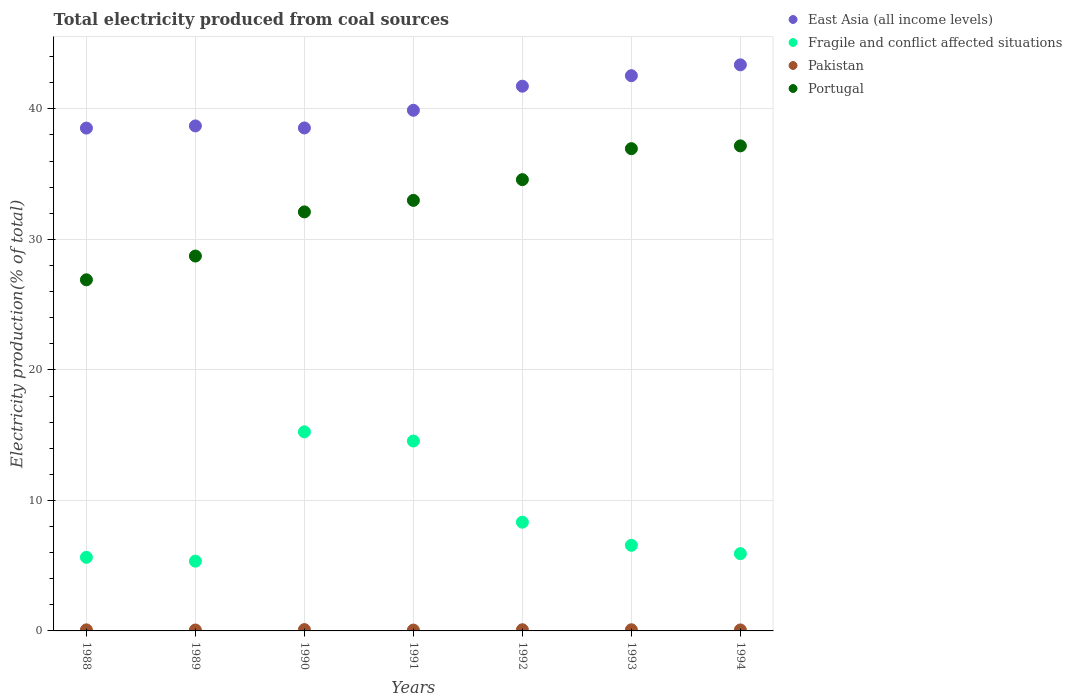How many different coloured dotlines are there?
Your answer should be compact. 4. What is the total electricity produced in Pakistan in 1988?
Offer a very short reply. 0.08. Across all years, what is the maximum total electricity produced in Pakistan?
Keep it short and to the point. 0.1. Across all years, what is the minimum total electricity produced in Portugal?
Make the answer very short. 26.9. In which year was the total electricity produced in Portugal minimum?
Provide a succinct answer. 1988. What is the total total electricity produced in Portugal in the graph?
Give a very brief answer. 229.42. What is the difference between the total electricity produced in Fragile and conflict affected situations in 1990 and that in 1992?
Ensure brevity in your answer.  6.92. What is the difference between the total electricity produced in Portugal in 1992 and the total electricity produced in Pakistan in 1989?
Your answer should be very brief. 34.51. What is the average total electricity produced in East Asia (all income levels) per year?
Your answer should be compact. 40.47. In the year 1990, what is the difference between the total electricity produced in East Asia (all income levels) and total electricity produced in Portugal?
Offer a very short reply. 6.43. What is the ratio of the total electricity produced in Portugal in 1988 to that in 1994?
Your response must be concise. 0.72. Is the difference between the total electricity produced in East Asia (all income levels) in 1993 and 1994 greater than the difference between the total electricity produced in Portugal in 1993 and 1994?
Provide a short and direct response. No. What is the difference between the highest and the second highest total electricity produced in East Asia (all income levels)?
Offer a terse response. 0.83. What is the difference between the highest and the lowest total electricity produced in Fragile and conflict affected situations?
Give a very brief answer. 9.91. In how many years, is the total electricity produced in Fragile and conflict affected situations greater than the average total electricity produced in Fragile and conflict affected situations taken over all years?
Make the answer very short. 2. Is the sum of the total electricity produced in Portugal in 1992 and 1993 greater than the maximum total electricity produced in Pakistan across all years?
Make the answer very short. Yes. Is it the case that in every year, the sum of the total electricity produced in Pakistan and total electricity produced in Portugal  is greater than the sum of total electricity produced in East Asia (all income levels) and total electricity produced in Fragile and conflict affected situations?
Provide a short and direct response. No. Is it the case that in every year, the sum of the total electricity produced in Fragile and conflict affected situations and total electricity produced in Portugal  is greater than the total electricity produced in East Asia (all income levels)?
Offer a very short reply. No. Does the total electricity produced in Portugal monotonically increase over the years?
Your response must be concise. Yes. Is the total electricity produced in East Asia (all income levels) strictly greater than the total electricity produced in Pakistan over the years?
Make the answer very short. Yes. Is the total electricity produced in Portugal strictly less than the total electricity produced in Fragile and conflict affected situations over the years?
Offer a terse response. No. How many years are there in the graph?
Provide a short and direct response. 7. Does the graph contain grids?
Provide a short and direct response. Yes. How many legend labels are there?
Offer a very short reply. 4. What is the title of the graph?
Give a very brief answer. Total electricity produced from coal sources. What is the label or title of the X-axis?
Keep it short and to the point. Years. What is the label or title of the Y-axis?
Your response must be concise. Electricity production(% of total). What is the Electricity production(% of total) in East Asia (all income levels) in 1988?
Your response must be concise. 38.53. What is the Electricity production(% of total) in Fragile and conflict affected situations in 1988?
Give a very brief answer. 5.64. What is the Electricity production(% of total) in Pakistan in 1988?
Keep it short and to the point. 0.08. What is the Electricity production(% of total) of Portugal in 1988?
Offer a very short reply. 26.9. What is the Electricity production(% of total) in East Asia (all income levels) in 1989?
Give a very brief answer. 38.7. What is the Electricity production(% of total) in Fragile and conflict affected situations in 1989?
Ensure brevity in your answer.  5.35. What is the Electricity production(% of total) in Pakistan in 1989?
Make the answer very short. 0.07. What is the Electricity production(% of total) in Portugal in 1989?
Ensure brevity in your answer.  28.73. What is the Electricity production(% of total) of East Asia (all income levels) in 1990?
Your response must be concise. 38.54. What is the Electricity production(% of total) in Fragile and conflict affected situations in 1990?
Your response must be concise. 15.25. What is the Electricity production(% of total) of Pakistan in 1990?
Give a very brief answer. 0.1. What is the Electricity production(% of total) of Portugal in 1990?
Your response must be concise. 32.11. What is the Electricity production(% of total) in East Asia (all income levels) in 1991?
Your response must be concise. 39.89. What is the Electricity production(% of total) in Fragile and conflict affected situations in 1991?
Provide a succinct answer. 14.55. What is the Electricity production(% of total) in Pakistan in 1991?
Provide a short and direct response. 0.07. What is the Electricity production(% of total) of Portugal in 1991?
Provide a short and direct response. 32.99. What is the Electricity production(% of total) in East Asia (all income levels) in 1992?
Ensure brevity in your answer.  41.74. What is the Electricity production(% of total) of Fragile and conflict affected situations in 1992?
Make the answer very short. 8.33. What is the Electricity production(% of total) in Pakistan in 1992?
Offer a very short reply. 0.09. What is the Electricity production(% of total) in Portugal in 1992?
Provide a short and direct response. 34.58. What is the Electricity production(% of total) in East Asia (all income levels) in 1993?
Offer a very short reply. 42.55. What is the Electricity production(% of total) in Fragile and conflict affected situations in 1993?
Offer a terse response. 6.56. What is the Electricity production(% of total) in Pakistan in 1993?
Keep it short and to the point. 0.09. What is the Electricity production(% of total) in Portugal in 1993?
Your response must be concise. 36.95. What is the Electricity production(% of total) of East Asia (all income levels) in 1994?
Your answer should be very brief. 43.38. What is the Electricity production(% of total) in Fragile and conflict affected situations in 1994?
Give a very brief answer. 5.92. What is the Electricity production(% of total) in Pakistan in 1994?
Give a very brief answer. 0.07. What is the Electricity production(% of total) of Portugal in 1994?
Give a very brief answer. 37.17. Across all years, what is the maximum Electricity production(% of total) in East Asia (all income levels)?
Your answer should be compact. 43.38. Across all years, what is the maximum Electricity production(% of total) in Fragile and conflict affected situations?
Your answer should be very brief. 15.25. Across all years, what is the maximum Electricity production(% of total) in Pakistan?
Give a very brief answer. 0.1. Across all years, what is the maximum Electricity production(% of total) in Portugal?
Your response must be concise. 37.17. Across all years, what is the minimum Electricity production(% of total) in East Asia (all income levels)?
Your answer should be compact. 38.53. Across all years, what is the minimum Electricity production(% of total) in Fragile and conflict affected situations?
Ensure brevity in your answer.  5.35. Across all years, what is the minimum Electricity production(% of total) in Pakistan?
Offer a very short reply. 0.07. Across all years, what is the minimum Electricity production(% of total) in Portugal?
Offer a terse response. 26.9. What is the total Electricity production(% of total) in East Asia (all income levels) in the graph?
Your response must be concise. 283.32. What is the total Electricity production(% of total) in Fragile and conflict affected situations in the graph?
Your response must be concise. 61.6. What is the total Electricity production(% of total) in Pakistan in the graph?
Your answer should be very brief. 0.57. What is the total Electricity production(% of total) of Portugal in the graph?
Your answer should be very brief. 229.42. What is the difference between the Electricity production(% of total) of East Asia (all income levels) in 1988 and that in 1989?
Offer a terse response. -0.17. What is the difference between the Electricity production(% of total) in Fragile and conflict affected situations in 1988 and that in 1989?
Provide a succinct answer. 0.29. What is the difference between the Electricity production(% of total) of Pakistan in 1988 and that in 1989?
Offer a terse response. 0.01. What is the difference between the Electricity production(% of total) of Portugal in 1988 and that in 1989?
Make the answer very short. -1.82. What is the difference between the Electricity production(% of total) of East Asia (all income levels) in 1988 and that in 1990?
Your response must be concise. -0.01. What is the difference between the Electricity production(% of total) of Fragile and conflict affected situations in 1988 and that in 1990?
Provide a succinct answer. -9.62. What is the difference between the Electricity production(% of total) in Pakistan in 1988 and that in 1990?
Give a very brief answer. -0.02. What is the difference between the Electricity production(% of total) in Portugal in 1988 and that in 1990?
Ensure brevity in your answer.  -5.2. What is the difference between the Electricity production(% of total) in East Asia (all income levels) in 1988 and that in 1991?
Make the answer very short. -1.36. What is the difference between the Electricity production(% of total) of Fragile and conflict affected situations in 1988 and that in 1991?
Keep it short and to the point. -8.91. What is the difference between the Electricity production(% of total) in Pakistan in 1988 and that in 1991?
Ensure brevity in your answer.  0.02. What is the difference between the Electricity production(% of total) of Portugal in 1988 and that in 1991?
Offer a very short reply. -6.09. What is the difference between the Electricity production(% of total) of East Asia (all income levels) in 1988 and that in 1992?
Offer a terse response. -3.21. What is the difference between the Electricity production(% of total) in Fragile and conflict affected situations in 1988 and that in 1992?
Offer a terse response. -2.69. What is the difference between the Electricity production(% of total) of Pakistan in 1988 and that in 1992?
Keep it short and to the point. -0.01. What is the difference between the Electricity production(% of total) in Portugal in 1988 and that in 1992?
Ensure brevity in your answer.  -7.67. What is the difference between the Electricity production(% of total) in East Asia (all income levels) in 1988 and that in 1993?
Give a very brief answer. -4.02. What is the difference between the Electricity production(% of total) of Fragile and conflict affected situations in 1988 and that in 1993?
Provide a succinct answer. -0.92. What is the difference between the Electricity production(% of total) in Pakistan in 1988 and that in 1993?
Your response must be concise. -0.01. What is the difference between the Electricity production(% of total) in Portugal in 1988 and that in 1993?
Your answer should be very brief. -10.05. What is the difference between the Electricity production(% of total) in East Asia (all income levels) in 1988 and that in 1994?
Offer a terse response. -4.85. What is the difference between the Electricity production(% of total) of Fragile and conflict affected situations in 1988 and that in 1994?
Make the answer very short. -0.28. What is the difference between the Electricity production(% of total) in Pakistan in 1988 and that in 1994?
Give a very brief answer. 0.01. What is the difference between the Electricity production(% of total) of Portugal in 1988 and that in 1994?
Ensure brevity in your answer.  -10.26. What is the difference between the Electricity production(% of total) in East Asia (all income levels) in 1989 and that in 1990?
Ensure brevity in your answer.  0.16. What is the difference between the Electricity production(% of total) of Fragile and conflict affected situations in 1989 and that in 1990?
Your answer should be compact. -9.91. What is the difference between the Electricity production(% of total) in Pakistan in 1989 and that in 1990?
Your answer should be compact. -0.03. What is the difference between the Electricity production(% of total) in Portugal in 1989 and that in 1990?
Provide a succinct answer. -3.38. What is the difference between the Electricity production(% of total) of East Asia (all income levels) in 1989 and that in 1991?
Keep it short and to the point. -1.2. What is the difference between the Electricity production(% of total) in Fragile and conflict affected situations in 1989 and that in 1991?
Your answer should be very brief. -9.21. What is the difference between the Electricity production(% of total) of Pakistan in 1989 and that in 1991?
Your answer should be compact. 0. What is the difference between the Electricity production(% of total) of Portugal in 1989 and that in 1991?
Your response must be concise. -4.27. What is the difference between the Electricity production(% of total) of East Asia (all income levels) in 1989 and that in 1992?
Ensure brevity in your answer.  -3.04. What is the difference between the Electricity production(% of total) of Fragile and conflict affected situations in 1989 and that in 1992?
Your response must be concise. -2.98. What is the difference between the Electricity production(% of total) of Pakistan in 1989 and that in 1992?
Your answer should be compact. -0.02. What is the difference between the Electricity production(% of total) in Portugal in 1989 and that in 1992?
Your answer should be very brief. -5.85. What is the difference between the Electricity production(% of total) in East Asia (all income levels) in 1989 and that in 1993?
Provide a succinct answer. -3.85. What is the difference between the Electricity production(% of total) in Fragile and conflict affected situations in 1989 and that in 1993?
Your answer should be very brief. -1.21. What is the difference between the Electricity production(% of total) in Pakistan in 1989 and that in 1993?
Make the answer very short. -0.02. What is the difference between the Electricity production(% of total) of Portugal in 1989 and that in 1993?
Provide a short and direct response. -8.23. What is the difference between the Electricity production(% of total) in East Asia (all income levels) in 1989 and that in 1994?
Ensure brevity in your answer.  -4.68. What is the difference between the Electricity production(% of total) of Fragile and conflict affected situations in 1989 and that in 1994?
Your answer should be compact. -0.57. What is the difference between the Electricity production(% of total) of Pakistan in 1989 and that in 1994?
Your response must be concise. -0.01. What is the difference between the Electricity production(% of total) of Portugal in 1989 and that in 1994?
Your answer should be very brief. -8.44. What is the difference between the Electricity production(% of total) of East Asia (all income levels) in 1990 and that in 1991?
Your answer should be compact. -1.36. What is the difference between the Electricity production(% of total) in Fragile and conflict affected situations in 1990 and that in 1991?
Keep it short and to the point. 0.7. What is the difference between the Electricity production(% of total) of Pakistan in 1990 and that in 1991?
Offer a terse response. 0.04. What is the difference between the Electricity production(% of total) in Portugal in 1990 and that in 1991?
Your answer should be very brief. -0.88. What is the difference between the Electricity production(% of total) of East Asia (all income levels) in 1990 and that in 1992?
Provide a succinct answer. -3.2. What is the difference between the Electricity production(% of total) of Fragile and conflict affected situations in 1990 and that in 1992?
Provide a short and direct response. 6.92. What is the difference between the Electricity production(% of total) in Pakistan in 1990 and that in 1992?
Keep it short and to the point. 0.01. What is the difference between the Electricity production(% of total) of Portugal in 1990 and that in 1992?
Offer a very short reply. -2.47. What is the difference between the Electricity production(% of total) of East Asia (all income levels) in 1990 and that in 1993?
Ensure brevity in your answer.  -4.01. What is the difference between the Electricity production(% of total) in Fragile and conflict affected situations in 1990 and that in 1993?
Ensure brevity in your answer.  8.69. What is the difference between the Electricity production(% of total) in Pakistan in 1990 and that in 1993?
Provide a succinct answer. 0.01. What is the difference between the Electricity production(% of total) of Portugal in 1990 and that in 1993?
Keep it short and to the point. -4.85. What is the difference between the Electricity production(% of total) in East Asia (all income levels) in 1990 and that in 1994?
Your response must be concise. -4.84. What is the difference between the Electricity production(% of total) of Fragile and conflict affected situations in 1990 and that in 1994?
Ensure brevity in your answer.  9.33. What is the difference between the Electricity production(% of total) of Pakistan in 1990 and that in 1994?
Ensure brevity in your answer.  0.03. What is the difference between the Electricity production(% of total) of Portugal in 1990 and that in 1994?
Make the answer very short. -5.06. What is the difference between the Electricity production(% of total) in East Asia (all income levels) in 1991 and that in 1992?
Offer a very short reply. -1.85. What is the difference between the Electricity production(% of total) in Fragile and conflict affected situations in 1991 and that in 1992?
Your response must be concise. 6.22. What is the difference between the Electricity production(% of total) in Pakistan in 1991 and that in 1992?
Ensure brevity in your answer.  -0.02. What is the difference between the Electricity production(% of total) in Portugal in 1991 and that in 1992?
Offer a terse response. -1.59. What is the difference between the Electricity production(% of total) in East Asia (all income levels) in 1991 and that in 1993?
Offer a terse response. -2.65. What is the difference between the Electricity production(% of total) in Fragile and conflict affected situations in 1991 and that in 1993?
Provide a short and direct response. 7.99. What is the difference between the Electricity production(% of total) of Pakistan in 1991 and that in 1993?
Offer a terse response. -0.02. What is the difference between the Electricity production(% of total) of Portugal in 1991 and that in 1993?
Provide a short and direct response. -3.96. What is the difference between the Electricity production(% of total) of East Asia (all income levels) in 1991 and that in 1994?
Ensure brevity in your answer.  -3.48. What is the difference between the Electricity production(% of total) of Fragile and conflict affected situations in 1991 and that in 1994?
Your answer should be very brief. 8.63. What is the difference between the Electricity production(% of total) of Pakistan in 1991 and that in 1994?
Your response must be concise. -0.01. What is the difference between the Electricity production(% of total) in Portugal in 1991 and that in 1994?
Provide a short and direct response. -4.18. What is the difference between the Electricity production(% of total) of East Asia (all income levels) in 1992 and that in 1993?
Your answer should be compact. -0.81. What is the difference between the Electricity production(% of total) of Fragile and conflict affected situations in 1992 and that in 1993?
Offer a very short reply. 1.77. What is the difference between the Electricity production(% of total) of Pakistan in 1992 and that in 1993?
Keep it short and to the point. 0. What is the difference between the Electricity production(% of total) of Portugal in 1992 and that in 1993?
Your answer should be compact. -2.37. What is the difference between the Electricity production(% of total) of East Asia (all income levels) in 1992 and that in 1994?
Ensure brevity in your answer.  -1.64. What is the difference between the Electricity production(% of total) of Fragile and conflict affected situations in 1992 and that in 1994?
Ensure brevity in your answer.  2.41. What is the difference between the Electricity production(% of total) in Pakistan in 1992 and that in 1994?
Keep it short and to the point. 0.02. What is the difference between the Electricity production(% of total) of Portugal in 1992 and that in 1994?
Give a very brief answer. -2.59. What is the difference between the Electricity production(% of total) in East Asia (all income levels) in 1993 and that in 1994?
Your answer should be very brief. -0.83. What is the difference between the Electricity production(% of total) of Fragile and conflict affected situations in 1993 and that in 1994?
Offer a very short reply. 0.64. What is the difference between the Electricity production(% of total) of Pakistan in 1993 and that in 1994?
Keep it short and to the point. 0.01. What is the difference between the Electricity production(% of total) of Portugal in 1993 and that in 1994?
Provide a short and direct response. -0.21. What is the difference between the Electricity production(% of total) in East Asia (all income levels) in 1988 and the Electricity production(% of total) in Fragile and conflict affected situations in 1989?
Your answer should be compact. 33.18. What is the difference between the Electricity production(% of total) of East Asia (all income levels) in 1988 and the Electricity production(% of total) of Pakistan in 1989?
Offer a very short reply. 38.46. What is the difference between the Electricity production(% of total) in East Asia (all income levels) in 1988 and the Electricity production(% of total) in Portugal in 1989?
Keep it short and to the point. 9.8. What is the difference between the Electricity production(% of total) of Fragile and conflict affected situations in 1988 and the Electricity production(% of total) of Pakistan in 1989?
Your response must be concise. 5.57. What is the difference between the Electricity production(% of total) in Fragile and conflict affected situations in 1988 and the Electricity production(% of total) in Portugal in 1989?
Ensure brevity in your answer.  -23.09. What is the difference between the Electricity production(% of total) of Pakistan in 1988 and the Electricity production(% of total) of Portugal in 1989?
Provide a short and direct response. -28.64. What is the difference between the Electricity production(% of total) of East Asia (all income levels) in 1988 and the Electricity production(% of total) of Fragile and conflict affected situations in 1990?
Make the answer very short. 23.27. What is the difference between the Electricity production(% of total) of East Asia (all income levels) in 1988 and the Electricity production(% of total) of Pakistan in 1990?
Your response must be concise. 38.43. What is the difference between the Electricity production(% of total) of East Asia (all income levels) in 1988 and the Electricity production(% of total) of Portugal in 1990?
Provide a short and direct response. 6.42. What is the difference between the Electricity production(% of total) of Fragile and conflict affected situations in 1988 and the Electricity production(% of total) of Pakistan in 1990?
Your response must be concise. 5.54. What is the difference between the Electricity production(% of total) of Fragile and conflict affected situations in 1988 and the Electricity production(% of total) of Portugal in 1990?
Provide a short and direct response. -26.47. What is the difference between the Electricity production(% of total) of Pakistan in 1988 and the Electricity production(% of total) of Portugal in 1990?
Give a very brief answer. -32.03. What is the difference between the Electricity production(% of total) in East Asia (all income levels) in 1988 and the Electricity production(% of total) in Fragile and conflict affected situations in 1991?
Offer a terse response. 23.98. What is the difference between the Electricity production(% of total) in East Asia (all income levels) in 1988 and the Electricity production(% of total) in Pakistan in 1991?
Your answer should be very brief. 38.46. What is the difference between the Electricity production(% of total) of East Asia (all income levels) in 1988 and the Electricity production(% of total) of Portugal in 1991?
Keep it short and to the point. 5.54. What is the difference between the Electricity production(% of total) of Fragile and conflict affected situations in 1988 and the Electricity production(% of total) of Pakistan in 1991?
Offer a very short reply. 5.57. What is the difference between the Electricity production(% of total) of Fragile and conflict affected situations in 1988 and the Electricity production(% of total) of Portugal in 1991?
Provide a succinct answer. -27.35. What is the difference between the Electricity production(% of total) of Pakistan in 1988 and the Electricity production(% of total) of Portugal in 1991?
Ensure brevity in your answer.  -32.91. What is the difference between the Electricity production(% of total) of East Asia (all income levels) in 1988 and the Electricity production(% of total) of Fragile and conflict affected situations in 1992?
Give a very brief answer. 30.2. What is the difference between the Electricity production(% of total) in East Asia (all income levels) in 1988 and the Electricity production(% of total) in Pakistan in 1992?
Your response must be concise. 38.44. What is the difference between the Electricity production(% of total) of East Asia (all income levels) in 1988 and the Electricity production(% of total) of Portugal in 1992?
Provide a succinct answer. 3.95. What is the difference between the Electricity production(% of total) of Fragile and conflict affected situations in 1988 and the Electricity production(% of total) of Pakistan in 1992?
Ensure brevity in your answer.  5.55. What is the difference between the Electricity production(% of total) in Fragile and conflict affected situations in 1988 and the Electricity production(% of total) in Portugal in 1992?
Your answer should be very brief. -28.94. What is the difference between the Electricity production(% of total) in Pakistan in 1988 and the Electricity production(% of total) in Portugal in 1992?
Your answer should be compact. -34.5. What is the difference between the Electricity production(% of total) in East Asia (all income levels) in 1988 and the Electricity production(% of total) in Fragile and conflict affected situations in 1993?
Keep it short and to the point. 31.97. What is the difference between the Electricity production(% of total) in East Asia (all income levels) in 1988 and the Electricity production(% of total) in Pakistan in 1993?
Give a very brief answer. 38.44. What is the difference between the Electricity production(% of total) of East Asia (all income levels) in 1988 and the Electricity production(% of total) of Portugal in 1993?
Give a very brief answer. 1.58. What is the difference between the Electricity production(% of total) in Fragile and conflict affected situations in 1988 and the Electricity production(% of total) in Pakistan in 1993?
Provide a succinct answer. 5.55. What is the difference between the Electricity production(% of total) of Fragile and conflict affected situations in 1988 and the Electricity production(% of total) of Portugal in 1993?
Provide a short and direct response. -31.31. What is the difference between the Electricity production(% of total) of Pakistan in 1988 and the Electricity production(% of total) of Portugal in 1993?
Provide a succinct answer. -36.87. What is the difference between the Electricity production(% of total) of East Asia (all income levels) in 1988 and the Electricity production(% of total) of Fragile and conflict affected situations in 1994?
Ensure brevity in your answer.  32.61. What is the difference between the Electricity production(% of total) in East Asia (all income levels) in 1988 and the Electricity production(% of total) in Pakistan in 1994?
Ensure brevity in your answer.  38.45. What is the difference between the Electricity production(% of total) of East Asia (all income levels) in 1988 and the Electricity production(% of total) of Portugal in 1994?
Give a very brief answer. 1.36. What is the difference between the Electricity production(% of total) in Fragile and conflict affected situations in 1988 and the Electricity production(% of total) in Pakistan in 1994?
Your answer should be compact. 5.56. What is the difference between the Electricity production(% of total) of Fragile and conflict affected situations in 1988 and the Electricity production(% of total) of Portugal in 1994?
Your response must be concise. -31.53. What is the difference between the Electricity production(% of total) in Pakistan in 1988 and the Electricity production(% of total) in Portugal in 1994?
Your answer should be very brief. -37.08. What is the difference between the Electricity production(% of total) in East Asia (all income levels) in 1989 and the Electricity production(% of total) in Fragile and conflict affected situations in 1990?
Provide a short and direct response. 23.44. What is the difference between the Electricity production(% of total) of East Asia (all income levels) in 1989 and the Electricity production(% of total) of Pakistan in 1990?
Provide a succinct answer. 38.59. What is the difference between the Electricity production(% of total) in East Asia (all income levels) in 1989 and the Electricity production(% of total) in Portugal in 1990?
Offer a very short reply. 6.59. What is the difference between the Electricity production(% of total) in Fragile and conflict affected situations in 1989 and the Electricity production(% of total) in Pakistan in 1990?
Your response must be concise. 5.25. What is the difference between the Electricity production(% of total) in Fragile and conflict affected situations in 1989 and the Electricity production(% of total) in Portugal in 1990?
Provide a short and direct response. -26.76. What is the difference between the Electricity production(% of total) of Pakistan in 1989 and the Electricity production(% of total) of Portugal in 1990?
Give a very brief answer. -32.04. What is the difference between the Electricity production(% of total) in East Asia (all income levels) in 1989 and the Electricity production(% of total) in Fragile and conflict affected situations in 1991?
Keep it short and to the point. 24.14. What is the difference between the Electricity production(% of total) in East Asia (all income levels) in 1989 and the Electricity production(% of total) in Pakistan in 1991?
Keep it short and to the point. 38.63. What is the difference between the Electricity production(% of total) of East Asia (all income levels) in 1989 and the Electricity production(% of total) of Portugal in 1991?
Give a very brief answer. 5.71. What is the difference between the Electricity production(% of total) of Fragile and conflict affected situations in 1989 and the Electricity production(% of total) of Pakistan in 1991?
Your answer should be compact. 5.28. What is the difference between the Electricity production(% of total) in Fragile and conflict affected situations in 1989 and the Electricity production(% of total) in Portugal in 1991?
Your answer should be very brief. -27.64. What is the difference between the Electricity production(% of total) in Pakistan in 1989 and the Electricity production(% of total) in Portugal in 1991?
Make the answer very short. -32.92. What is the difference between the Electricity production(% of total) of East Asia (all income levels) in 1989 and the Electricity production(% of total) of Fragile and conflict affected situations in 1992?
Your answer should be compact. 30.36. What is the difference between the Electricity production(% of total) in East Asia (all income levels) in 1989 and the Electricity production(% of total) in Pakistan in 1992?
Offer a terse response. 38.61. What is the difference between the Electricity production(% of total) in East Asia (all income levels) in 1989 and the Electricity production(% of total) in Portugal in 1992?
Offer a very short reply. 4.12. What is the difference between the Electricity production(% of total) of Fragile and conflict affected situations in 1989 and the Electricity production(% of total) of Pakistan in 1992?
Offer a very short reply. 5.26. What is the difference between the Electricity production(% of total) in Fragile and conflict affected situations in 1989 and the Electricity production(% of total) in Portugal in 1992?
Give a very brief answer. -29.23. What is the difference between the Electricity production(% of total) of Pakistan in 1989 and the Electricity production(% of total) of Portugal in 1992?
Provide a short and direct response. -34.51. What is the difference between the Electricity production(% of total) of East Asia (all income levels) in 1989 and the Electricity production(% of total) of Fragile and conflict affected situations in 1993?
Give a very brief answer. 32.14. What is the difference between the Electricity production(% of total) of East Asia (all income levels) in 1989 and the Electricity production(% of total) of Pakistan in 1993?
Offer a terse response. 38.61. What is the difference between the Electricity production(% of total) in East Asia (all income levels) in 1989 and the Electricity production(% of total) in Portugal in 1993?
Make the answer very short. 1.74. What is the difference between the Electricity production(% of total) in Fragile and conflict affected situations in 1989 and the Electricity production(% of total) in Pakistan in 1993?
Provide a succinct answer. 5.26. What is the difference between the Electricity production(% of total) in Fragile and conflict affected situations in 1989 and the Electricity production(% of total) in Portugal in 1993?
Offer a terse response. -31.61. What is the difference between the Electricity production(% of total) in Pakistan in 1989 and the Electricity production(% of total) in Portugal in 1993?
Give a very brief answer. -36.88. What is the difference between the Electricity production(% of total) in East Asia (all income levels) in 1989 and the Electricity production(% of total) in Fragile and conflict affected situations in 1994?
Your answer should be very brief. 32.77. What is the difference between the Electricity production(% of total) of East Asia (all income levels) in 1989 and the Electricity production(% of total) of Pakistan in 1994?
Give a very brief answer. 38.62. What is the difference between the Electricity production(% of total) in East Asia (all income levels) in 1989 and the Electricity production(% of total) in Portugal in 1994?
Give a very brief answer. 1.53. What is the difference between the Electricity production(% of total) in Fragile and conflict affected situations in 1989 and the Electricity production(% of total) in Pakistan in 1994?
Offer a terse response. 5.27. What is the difference between the Electricity production(% of total) in Fragile and conflict affected situations in 1989 and the Electricity production(% of total) in Portugal in 1994?
Provide a succinct answer. -31.82. What is the difference between the Electricity production(% of total) in Pakistan in 1989 and the Electricity production(% of total) in Portugal in 1994?
Make the answer very short. -37.1. What is the difference between the Electricity production(% of total) of East Asia (all income levels) in 1990 and the Electricity production(% of total) of Fragile and conflict affected situations in 1991?
Make the answer very short. 23.99. What is the difference between the Electricity production(% of total) in East Asia (all income levels) in 1990 and the Electricity production(% of total) in Pakistan in 1991?
Provide a succinct answer. 38.47. What is the difference between the Electricity production(% of total) in East Asia (all income levels) in 1990 and the Electricity production(% of total) in Portugal in 1991?
Offer a very short reply. 5.55. What is the difference between the Electricity production(% of total) in Fragile and conflict affected situations in 1990 and the Electricity production(% of total) in Pakistan in 1991?
Offer a very short reply. 15.19. What is the difference between the Electricity production(% of total) in Fragile and conflict affected situations in 1990 and the Electricity production(% of total) in Portugal in 1991?
Keep it short and to the point. -17.74. What is the difference between the Electricity production(% of total) of Pakistan in 1990 and the Electricity production(% of total) of Portugal in 1991?
Your answer should be very brief. -32.89. What is the difference between the Electricity production(% of total) in East Asia (all income levels) in 1990 and the Electricity production(% of total) in Fragile and conflict affected situations in 1992?
Ensure brevity in your answer.  30.21. What is the difference between the Electricity production(% of total) in East Asia (all income levels) in 1990 and the Electricity production(% of total) in Pakistan in 1992?
Your response must be concise. 38.45. What is the difference between the Electricity production(% of total) of East Asia (all income levels) in 1990 and the Electricity production(% of total) of Portugal in 1992?
Offer a very short reply. 3.96. What is the difference between the Electricity production(% of total) in Fragile and conflict affected situations in 1990 and the Electricity production(% of total) in Pakistan in 1992?
Ensure brevity in your answer.  15.16. What is the difference between the Electricity production(% of total) of Fragile and conflict affected situations in 1990 and the Electricity production(% of total) of Portugal in 1992?
Ensure brevity in your answer.  -19.32. What is the difference between the Electricity production(% of total) in Pakistan in 1990 and the Electricity production(% of total) in Portugal in 1992?
Offer a very short reply. -34.48. What is the difference between the Electricity production(% of total) in East Asia (all income levels) in 1990 and the Electricity production(% of total) in Fragile and conflict affected situations in 1993?
Your response must be concise. 31.98. What is the difference between the Electricity production(% of total) in East Asia (all income levels) in 1990 and the Electricity production(% of total) in Pakistan in 1993?
Keep it short and to the point. 38.45. What is the difference between the Electricity production(% of total) of East Asia (all income levels) in 1990 and the Electricity production(% of total) of Portugal in 1993?
Offer a terse response. 1.59. What is the difference between the Electricity production(% of total) in Fragile and conflict affected situations in 1990 and the Electricity production(% of total) in Pakistan in 1993?
Ensure brevity in your answer.  15.17. What is the difference between the Electricity production(% of total) of Fragile and conflict affected situations in 1990 and the Electricity production(% of total) of Portugal in 1993?
Provide a short and direct response. -21.7. What is the difference between the Electricity production(% of total) of Pakistan in 1990 and the Electricity production(% of total) of Portugal in 1993?
Your answer should be very brief. -36.85. What is the difference between the Electricity production(% of total) of East Asia (all income levels) in 1990 and the Electricity production(% of total) of Fragile and conflict affected situations in 1994?
Offer a very short reply. 32.62. What is the difference between the Electricity production(% of total) in East Asia (all income levels) in 1990 and the Electricity production(% of total) in Pakistan in 1994?
Your response must be concise. 38.46. What is the difference between the Electricity production(% of total) in East Asia (all income levels) in 1990 and the Electricity production(% of total) in Portugal in 1994?
Provide a short and direct response. 1.37. What is the difference between the Electricity production(% of total) of Fragile and conflict affected situations in 1990 and the Electricity production(% of total) of Pakistan in 1994?
Provide a short and direct response. 15.18. What is the difference between the Electricity production(% of total) of Fragile and conflict affected situations in 1990 and the Electricity production(% of total) of Portugal in 1994?
Ensure brevity in your answer.  -21.91. What is the difference between the Electricity production(% of total) of Pakistan in 1990 and the Electricity production(% of total) of Portugal in 1994?
Your response must be concise. -37.06. What is the difference between the Electricity production(% of total) in East Asia (all income levels) in 1991 and the Electricity production(% of total) in Fragile and conflict affected situations in 1992?
Keep it short and to the point. 31.56. What is the difference between the Electricity production(% of total) of East Asia (all income levels) in 1991 and the Electricity production(% of total) of Pakistan in 1992?
Offer a very short reply. 39.8. What is the difference between the Electricity production(% of total) of East Asia (all income levels) in 1991 and the Electricity production(% of total) of Portugal in 1992?
Your response must be concise. 5.32. What is the difference between the Electricity production(% of total) in Fragile and conflict affected situations in 1991 and the Electricity production(% of total) in Pakistan in 1992?
Your response must be concise. 14.46. What is the difference between the Electricity production(% of total) of Fragile and conflict affected situations in 1991 and the Electricity production(% of total) of Portugal in 1992?
Keep it short and to the point. -20.03. What is the difference between the Electricity production(% of total) in Pakistan in 1991 and the Electricity production(% of total) in Portugal in 1992?
Your answer should be very brief. -34.51. What is the difference between the Electricity production(% of total) in East Asia (all income levels) in 1991 and the Electricity production(% of total) in Fragile and conflict affected situations in 1993?
Provide a succinct answer. 33.33. What is the difference between the Electricity production(% of total) of East Asia (all income levels) in 1991 and the Electricity production(% of total) of Pakistan in 1993?
Provide a short and direct response. 39.81. What is the difference between the Electricity production(% of total) of East Asia (all income levels) in 1991 and the Electricity production(% of total) of Portugal in 1993?
Ensure brevity in your answer.  2.94. What is the difference between the Electricity production(% of total) of Fragile and conflict affected situations in 1991 and the Electricity production(% of total) of Pakistan in 1993?
Your answer should be very brief. 14.46. What is the difference between the Electricity production(% of total) of Fragile and conflict affected situations in 1991 and the Electricity production(% of total) of Portugal in 1993?
Offer a very short reply. -22.4. What is the difference between the Electricity production(% of total) in Pakistan in 1991 and the Electricity production(% of total) in Portugal in 1993?
Offer a very short reply. -36.89. What is the difference between the Electricity production(% of total) of East Asia (all income levels) in 1991 and the Electricity production(% of total) of Fragile and conflict affected situations in 1994?
Provide a short and direct response. 33.97. What is the difference between the Electricity production(% of total) in East Asia (all income levels) in 1991 and the Electricity production(% of total) in Pakistan in 1994?
Your response must be concise. 39.82. What is the difference between the Electricity production(% of total) in East Asia (all income levels) in 1991 and the Electricity production(% of total) in Portugal in 1994?
Your answer should be compact. 2.73. What is the difference between the Electricity production(% of total) in Fragile and conflict affected situations in 1991 and the Electricity production(% of total) in Pakistan in 1994?
Provide a succinct answer. 14.48. What is the difference between the Electricity production(% of total) of Fragile and conflict affected situations in 1991 and the Electricity production(% of total) of Portugal in 1994?
Offer a terse response. -22.61. What is the difference between the Electricity production(% of total) in Pakistan in 1991 and the Electricity production(% of total) in Portugal in 1994?
Make the answer very short. -37.1. What is the difference between the Electricity production(% of total) in East Asia (all income levels) in 1992 and the Electricity production(% of total) in Fragile and conflict affected situations in 1993?
Provide a short and direct response. 35.18. What is the difference between the Electricity production(% of total) in East Asia (all income levels) in 1992 and the Electricity production(% of total) in Pakistan in 1993?
Provide a succinct answer. 41.65. What is the difference between the Electricity production(% of total) in East Asia (all income levels) in 1992 and the Electricity production(% of total) in Portugal in 1993?
Provide a succinct answer. 4.79. What is the difference between the Electricity production(% of total) of Fragile and conflict affected situations in 1992 and the Electricity production(% of total) of Pakistan in 1993?
Keep it short and to the point. 8.24. What is the difference between the Electricity production(% of total) of Fragile and conflict affected situations in 1992 and the Electricity production(% of total) of Portugal in 1993?
Offer a terse response. -28.62. What is the difference between the Electricity production(% of total) of Pakistan in 1992 and the Electricity production(% of total) of Portugal in 1993?
Your answer should be compact. -36.86. What is the difference between the Electricity production(% of total) of East Asia (all income levels) in 1992 and the Electricity production(% of total) of Fragile and conflict affected situations in 1994?
Provide a succinct answer. 35.82. What is the difference between the Electricity production(% of total) of East Asia (all income levels) in 1992 and the Electricity production(% of total) of Pakistan in 1994?
Offer a very short reply. 41.67. What is the difference between the Electricity production(% of total) of East Asia (all income levels) in 1992 and the Electricity production(% of total) of Portugal in 1994?
Offer a terse response. 4.57. What is the difference between the Electricity production(% of total) in Fragile and conflict affected situations in 1992 and the Electricity production(% of total) in Pakistan in 1994?
Your answer should be compact. 8.26. What is the difference between the Electricity production(% of total) in Fragile and conflict affected situations in 1992 and the Electricity production(% of total) in Portugal in 1994?
Offer a very short reply. -28.83. What is the difference between the Electricity production(% of total) of Pakistan in 1992 and the Electricity production(% of total) of Portugal in 1994?
Provide a short and direct response. -37.08. What is the difference between the Electricity production(% of total) of East Asia (all income levels) in 1993 and the Electricity production(% of total) of Fragile and conflict affected situations in 1994?
Your response must be concise. 36.62. What is the difference between the Electricity production(% of total) in East Asia (all income levels) in 1993 and the Electricity production(% of total) in Pakistan in 1994?
Make the answer very short. 42.47. What is the difference between the Electricity production(% of total) in East Asia (all income levels) in 1993 and the Electricity production(% of total) in Portugal in 1994?
Keep it short and to the point. 5.38. What is the difference between the Electricity production(% of total) in Fragile and conflict affected situations in 1993 and the Electricity production(% of total) in Pakistan in 1994?
Ensure brevity in your answer.  6.49. What is the difference between the Electricity production(% of total) in Fragile and conflict affected situations in 1993 and the Electricity production(% of total) in Portugal in 1994?
Make the answer very short. -30.61. What is the difference between the Electricity production(% of total) in Pakistan in 1993 and the Electricity production(% of total) in Portugal in 1994?
Offer a terse response. -37.08. What is the average Electricity production(% of total) of East Asia (all income levels) per year?
Your answer should be very brief. 40.47. What is the average Electricity production(% of total) in Fragile and conflict affected situations per year?
Provide a succinct answer. 8.8. What is the average Electricity production(% of total) of Pakistan per year?
Offer a terse response. 0.08. What is the average Electricity production(% of total) of Portugal per year?
Ensure brevity in your answer.  32.77. In the year 1988, what is the difference between the Electricity production(% of total) of East Asia (all income levels) and Electricity production(% of total) of Fragile and conflict affected situations?
Offer a very short reply. 32.89. In the year 1988, what is the difference between the Electricity production(% of total) in East Asia (all income levels) and Electricity production(% of total) in Pakistan?
Ensure brevity in your answer.  38.45. In the year 1988, what is the difference between the Electricity production(% of total) in East Asia (all income levels) and Electricity production(% of total) in Portugal?
Give a very brief answer. 11.63. In the year 1988, what is the difference between the Electricity production(% of total) in Fragile and conflict affected situations and Electricity production(% of total) in Pakistan?
Offer a terse response. 5.56. In the year 1988, what is the difference between the Electricity production(% of total) of Fragile and conflict affected situations and Electricity production(% of total) of Portugal?
Keep it short and to the point. -21.27. In the year 1988, what is the difference between the Electricity production(% of total) in Pakistan and Electricity production(% of total) in Portugal?
Provide a succinct answer. -26.82. In the year 1989, what is the difference between the Electricity production(% of total) of East Asia (all income levels) and Electricity production(% of total) of Fragile and conflict affected situations?
Your answer should be compact. 33.35. In the year 1989, what is the difference between the Electricity production(% of total) in East Asia (all income levels) and Electricity production(% of total) in Pakistan?
Offer a very short reply. 38.63. In the year 1989, what is the difference between the Electricity production(% of total) of East Asia (all income levels) and Electricity production(% of total) of Portugal?
Provide a short and direct response. 9.97. In the year 1989, what is the difference between the Electricity production(% of total) of Fragile and conflict affected situations and Electricity production(% of total) of Pakistan?
Keep it short and to the point. 5.28. In the year 1989, what is the difference between the Electricity production(% of total) in Fragile and conflict affected situations and Electricity production(% of total) in Portugal?
Offer a terse response. -23.38. In the year 1989, what is the difference between the Electricity production(% of total) in Pakistan and Electricity production(% of total) in Portugal?
Provide a succinct answer. -28.66. In the year 1990, what is the difference between the Electricity production(% of total) of East Asia (all income levels) and Electricity production(% of total) of Fragile and conflict affected situations?
Offer a very short reply. 23.28. In the year 1990, what is the difference between the Electricity production(% of total) in East Asia (all income levels) and Electricity production(% of total) in Pakistan?
Provide a succinct answer. 38.44. In the year 1990, what is the difference between the Electricity production(% of total) of East Asia (all income levels) and Electricity production(% of total) of Portugal?
Offer a very short reply. 6.43. In the year 1990, what is the difference between the Electricity production(% of total) of Fragile and conflict affected situations and Electricity production(% of total) of Pakistan?
Your answer should be very brief. 15.15. In the year 1990, what is the difference between the Electricity production(% of total) of Fragile and conflict affected situations and Electricity production(% of total) of Portugal?
Make the answer very short. -16.85. In the year 1990, what is the difference between the Electricity production(% of total) of Pakistan and Electricity production(% of total) of Portugal?
Ensure brevity in your answer.  -32.01. In the year 1991, what is the difference between the Electricity production(% of total) in East Asia (all income levels) and Electricity production(% of total) in Fragile and conflict affected situations?
Provide a short and direct response. 25.34. In the year 1991, what is the difference between the Electricity production(% of total) in East Asia (all income levels) and Electricity production(% of total) in Pakistan?
Provide a succinct answer. 39.83. In the year 1991, what is the difference between the Electricity production(% of total) in East Asia (all income levels) and Electricity production(% of total) in Portugal?
Your answer should be compact. 6.9. In the year 1991, what is the difference between the Electricity production(% of total) in Fragile and conflict affected situations and Electricity production(% of total) in Pakistan?
Offer a terse response. 14.49. In the year 1991, what is the difference between the Electricity production(% of total) in Fragile and conflict affected situations and Electricity production(% of total) in Portugal?
Ensure brevity in your answer.  -18.44. In the year 1991, what is the difference between the Electricity production(% of total) in Pakistan and Electricity production(% of total) in Portugal?
Provide a succinct answer. -32.92. In the year 1992, what is the difference between the Electricity production(% of total) of East Asia (all income levels) and Electricity production(% of total) of Fragile and conflict affected situations?
Ensure brevity in your answer.  33.41. In the year 1992, what is the difference between the Electricity production(% of total) of East Asia (all income levels) and Electricity production(% of total) of Pakistan?
Offer a terse response. 41.65. In the year 1992, what is the difference between the Electricity production(% of total) of East Asia (all income levels) and Electricity production(% of total) of Portugal?
Provide a short and direct response. 7.16. In the year 1992, what is the difference between the Electricity production(% of total) of Fragile and conflict affected situations and Electricity production(% of total) of Pakistan?
Your answer should be very brief. 8.24. In the year 1992, what is the difference between the Electricity production(% of total) of Fragile and conflict affected situations and Electricity production(% of total) of Portugal?
Offer a terse response. -26.25. In the year 1992, what is the difference between the Electricity production(% of total) of Pakistan and Electricity production(% of total) of Portugal?
Your answer should be very brief. -34.49. In the year 1993, what is the difference between the Electricity production(% of total) of East Asia (all income levels) and Electricity production(% of total) of Fragile and conflict affected situations?
Offer a terse response. 35.98. In the year 1993, what is the difference between the Electricity production(% of total) of East Asia (all income levels) and Electricity production(% of total) of Pakistan?
Your response must be concise. 42.46. In the year 1993, what is the difference between the Electricity production(% of total) in East Asia (all income levels) and Electricity production(% of total) in Portugal?
Your answer should be very brief. 5.59. In the year 1993, what is the difference between the Electricity production(% of total) in Fragile and conflict affected situations and Electricity production(% of total) in Pakistan?
Your answer should be very brief. 6.47. In the year 1993, what is the difference between the Electricity production(% of total) in Fragile and conflict affected situations and Electricity production(% of total) in Portugal?
Your answer should be compact. -30.39. In the year 1993, what is the difference between the Electricity production(% of total) in Pakistan and Electricity production(% of total) in Portugal?
Offer a very short reply. -36.86. In the year 1994, what is the difference between the Electricity production(% of total) in East Asia (all income levels) and Electricity production(% of total) in Fragile and conflict affected situations?
Your answer should be very brief. 37.46. In the year 1994, what is the difference between the Electricity production(% of total) in East Asia (all income levels) and Electricity production(% of total) in Pakistan?
Your answer should be compact. 43.3. In the year 1994, what is the difference between the Electricity production(% of total) in East Asia (all income levels) and Electricity production(% of total) in Portugal?
Ensure brevity in your answer.  6.21. In the year 1994, what is the difference between the Electricity production(% of total) of Fragile and conflict affected situations and Electricity production(% of total) of Pakistan?
Your answer should be compact. 5.85. In the year 1994, what is the difference between the Electricity production(% of total) of Fragile and conflict affected situations and Electricity production(% of total) of Portugal?
Provide a short and direct response. -31.24. In the year 1994, what is the difference between the Electricity production(% of total) of Pakistan and Electricity production(% of total) of Portugal?
Your answer should be very brief. -37.09. What is the ratio of the Electricity production(% of total) in Fragile and conflict affected situations in 1988 to that in 1989?
Make the answer very short. 1.05. What is the ratio of the Electricity production(% of total) in Pakistan in 1988 to that in 1989?
Your answer should be compact. 1.18. What is the ratio of the Electricity production(% of total) of Portugal in 1988 to that in 1989?
Your answer should be very brief. 0.94. What is the ratio of the Electricity production(% of total) of Fragile and conflict affected situations in 1988 to that in 1990?
Ensure brevity in your answer.  0.37. What is the ratio of the Electricity production(% of total) of Pakistan in 1988 to that in 1990?
Make the answer very short. 0.81. What is the ratio of the Electricity production(% of total) of Portugal in 1988 to that in 1990?
Keep it short and to the point. 0.84. What is the ratio of the Electricity production(% of total) in East Asia (all income levels) in 1988 to that in 1991?
Give a very brief answer. 0.97. What is the ratio of the Electricity production(% of total) of Fragile and conflict affected situations in 1988 to that in 1991?
Provide a succinct answer. 0.39. What is the ratio of the Electricity production(% of total) of Pakistan in 1988 to that in 1991?
Make the answer very short. 1.24. What is the ratio of the Electricity production(% of total) of Portugal in 1988 to that in 1991?
Offer a terse response. 0.82. What is the ratio of the Electricity production(% of total) in East Asia (all income levels) in 1988 to that in 1992?
Give a very brief answer. 0.92. What is the ratio of the Electricity production(% of total) in Fragile and conflict affected situations in 1988 to that in 1992?
Give a very brief answer. 0.68. What is the ratio of the Electricity production(% of total) in Pakistan in 1988 to that in 1992?
Provide a succinct answer. 0.91. What is the ratio of the Electricity production(% of total) of Portugal in 1988 to that in 1992?
Keep it short and to the point. 0.78. What is the ratio of the Electricity production(% of total) in East Asia (all income levels) in 1988 to that in 1993?
Make the answer very short. 0.91. What is the ratio of the Electricity production(% of total) of Fragile and conflict affected situations in 1988 to that in 1993?
Your answer should be very brief. 0.86. What is the ratio of the Electricity production(% of total) of Pakistan in 1988 to that in 1993?
Make the answer very short. 0.92. What is the ratio of the Electricity production(% of total) in Portugal in 1988 to that in 1993?
Provide a short and direct response. 0.73. What is the ratio of the Electricity production(% of total) in East Asia (all income levels) in 1988 to that in 1994?
Provide a succinct answer. 0.89. What is the ratio of the Electricity production(% of total) of Pakistan in 1988 to that in 1994?
Ensure brevity in your answer.  1.09. What is the ratio of the Electricity production(% of total) of Portugal in 1988 to that in 1994?
Offer a very short reply. 0.72. What is the ratio of the Electricity production(% of total) of East Asia (all income levels) in 1989 to that in 1990?
Your response must be concise. 1. What is the ratio of the Electricity production(% of total) of Fragile and conflict affected situations in 1989 to that in 1990?
Your answer should be compact. 0.35. What is the ratio of the Electricity production(% of total) in Pakistan in 1989 to that in 1990?
Make the answer very short. 0.69. What is the ratio of the Electricity production(% of total) of Portugal in 1989 to that in 1990?
Provide a short and direct response. 0.89. What is the ratio of the Electricity production(% of total) of Fragile and conflict affected situations in 1989 to that in 1991?
Keep it short and to the point. 0.37. What is the ratio of the Electricity production(% of total) in Pakistan in 1989 to that in 1991?
Your response must be concise. 1.06. What is the ratio of the Electricity production(% of total) of Portugal in 1989 to that in 1991?
Provide a succinct answer. 0.87. What is the ratio of the Electricity production(% of total) of East Asia (all income levels) in 1989 to that in 1992?
Ensure brevity in your answer.  0.93. What is the ratio of the Electricity production(% of total) of Fragile and conflict affected situations in 1989 to that in 1992?
Offer a terse response. 0.64. What is the ratio of the Electricity production(% of total) of Pakistan in 1989 to that in 1992?
Make the answer very short. 0.77. What is the ratio of the Electricity production(% of total) of Portugal in 1989 to that in 1992?
Keep it short and to the point. 0.83. What is the ratio of the Electricity production(% of total) of East Asia (all income levels) in 1989 to that in 1993?
Give a very brief answer. 0.91. What is the ratio of the Electricity production(% of total) of Fragile and conflict affected situations in 1989 to that in 1993?
Provide a short and direct response. 0.81. What is the ratio of the Electricity production(% of total) of Pakistan in 1989 to that in 1993?
Provide a short and direct response. 0.78. What is the ratio of the Electricity production(% of total) in Portugal in 1989 to that in 1993?
Provide a short and direct response. 0.78. What is the ratio of the Electricity production(% of total) in East Asia (all income levels) in 1989 to that in 1994?
Your answer should be compact. 0.89. What is the ratio of the Electricity production(% of total) in Fragile and conflict affected situations in 1989 to that in 1994?
Ensure brevity in your answer.  0.9. What is the ratio of the Electricity production(% of total) of Pakistan in 1989 to that in 1994?
Provide a short and direct response. 0.93. What is the ratio of the Electricity production(% of total) in Portugal in 1989 to that in 1994?
Offer a very short reply. 0.77. What is the ratio of the Electricity production(% of total) in Fragile and conflict affected situations in 1990 to that in 1991?
Provide a succinct answer. 1.05. What is the ratio of the Electricity production(% of total) of Pakistan in 1990 to that in 1991?
Offer a terse response. 1.53. What is the ratio of the Electricity production(% of total) in Portugal in 1990 to that in 1991?
Keep it short and to the point. 0.97. What is the ratio of the Electricity production(% of total) in East Asia (all income levels) in 1990 to that in 1992?
Your answer should be compact. 0.92. What is the ratio of the Electricity production(% of total) in Fragile and conflict affected situations in 1990 to that in 1992?
Ensure brevity in your answer.  1.83. What is the ratio of the Electricity production(% of total) of Pakistan in 1990 to that in 1992?
Your answer should be compact. 1.12. What is the ratio of the Electricity production(% of total) of Portugal in 1990 to that in 1992?
Provide a succinct answer. 0.93. What is the ratio of the Electricity production(% of total) in East Asia (all income levels) in 1990 to that in 1993?
Your response must be concise. 0.91. What is the ratio of the Electricity production(% of total) of Fragile and conflict affected situations in 1990 to that in 1993?
Offer a terse response. 2.33. What is the ratio of the Electricity production(% of total) of Pakistan in 1990 to that in 1993?
Give a very brief answer. 1.14. What is the ratio of the Electricity production(% of total) of Portugal in 1990 to that in 1993?
Your response must be concise. 0.87. What is the ratio of the Electricity production(% of total) of East Asia (all income levels) in 1990 to that in 1994?
Offer a terse response. 0.89. What is the ratio of the Electricity production(% of total) of Fragile and conflict affected situations in 1990 to that in 1994?
Your answer should be very brief. 2.58. What is the ratio of the Electricity production(% of total) in Pakistan in 1990 to that in 1994?
Ensure brevity in your answer.  1.35. What is the ratio of the Electricity production(% of total) in Portugal in 1990 to that in 1994?
Offer a very short reply. 0.86. What is the ratio of the Electricity production(% of total) of East Asia (all income levels) in 1991 to that in 1992?
Provide a succinct answer. 0.96. What is the ratio of the Electricity production(% of total) of Fragile and conflict affected situations in 1991 to that in 1992?
Provide a succinct answer. 1.75. What is the ratio of the Electricity production(% of total) in Pakistan in 1991 to that in 1992?
Provide a succinct answer. 0.73. What is the ratio of the Electricity production(% of total) in Portugal in 1991 to that in 1992?
Offer a terse response. 0.95. What is the ratio of the Electricity production(% of total) of East Asia (all income levels) in 1991 to that in 1993?
Your response must be concise. 0.94. What is the ratio of the Electricity production(% of total) in Fragile and conflict affected situations in 1991 to that in 1993?
Offer a very short reply. 2.22. What is the ratio of the Electricity production(% of total) in Pakistan in 1991 to that in 1993?
Provide a short and direct response. 0.74. What is the ratio of the Electricity production(% of total) of Portugal in 1991 to that in 1993?
Keep it short and to the point. 0.89. What is the ratio of the Electricity production(% of total) in East Asia (all income levels) in 1991 to that in 1994?
Make the answer very short. 0.92. What is the ratio of the Electricity production(% of total) of Fragile and conflict affected situations in 1991 to that in 1994?
Offer a terse response. 2.46. What is the ratio of the Electricity production(% of total) of Pakistan in 1991 to that in 1994?
Give a very brief answer. 0.88. What is the ratio of the Electricity production(% of total) of Portugal in 1991 to that in 1994?
Your answer should be very brief. 0.89. What is the ratio of the Electricity production(% of total) in East Asia (all income levels) in 1992 to that in 1993?
Your answer should be very brief. 0.98. What is the ratio of the Electricity production(% of total) of Fragile and conflict affected situations in 1992 to that in 1993?
Your answer should be compact. 1.27. What is the ratio of the Electricity production(% of total) in Pakistan in 1992 to that in 1993?
Ensure brevity in your answer.  1.01. What is the ratio of the Electricity production(% of total) of Portugal in 1992 to that in 1993?
Provide a short and direct response. 0.94. What is the ratio of the Electricity production(% of total) of East Asia (all income levels) in 1992 to that in 1994?
Keep it short and to the point. 0.96. What is the ratio of the Electricity production(% of total) in Fragile and conflict affected situations in 1992 to that in 1994?
Ensure brevity in your answer.  1.41. What is the ratio of the Electricity production(% of total) of Pakistan in 1992 to that in 1994?
Ensure brevity in your answer.  1.21. What is the ratio of the Electricity production(% of total) of Portugal in 1992 to that in 1994?
Keep it short and to the point. 0.93. What is the ratio of the Electricity production(% of total) of East Asia (all income levels) in 1993 to that in 1994?
Ensure brevity in your answer.  0.98. What is the ratio of the Electricity production(% of total) of Fragile and conflict affected situations in 1993 to that in 1994?
Your response must be concise. 1.11. What is the ratio of the Electricity production(% of total) of Pakistan in 1993 to that in 1994?
Your answer should be compact. 1.19. What is the ratio of the Electricity production(% of total) in Portugal in 1993 to that in 1994?
Give a very brief answer. 0.99. What is the difference between the highest and the second highest Electricity production(% of total) in East Asia (all income levels)?
Offer a terse response. 0.83. What is the difference between the highest and the second highest Electricity production(% of total) in Fragile and conflict affected situations?
Provide a succinct answer. 0.7. What is the difference between the highest and the second highest Electricity production(% of total) of Pakistan?
Provide a short and direct response. 0.01. What is the difference between the highest and the second highest Electricity production(% of total) of Portugal?
Keep it short and to the point. 0.21. What is the difference between the highest and the lowest Electricity production(% of total) of East Asia (all income levels)?
Your answer should be compact. 4.85. What is the difference between the highest and the lowest Electricity production(% of total) in Fragile and conflict affected situations?
Provide a succinct answer. 9.91. What is the difference between the highest and the lowest Electricity production(% of total) in Pakistan?
Ensure brevity in your answer.  0.04. What is the difference between the highest and the lowest Electricity production(% of total) of Portugal?
Your response must be concise. 10.26. 